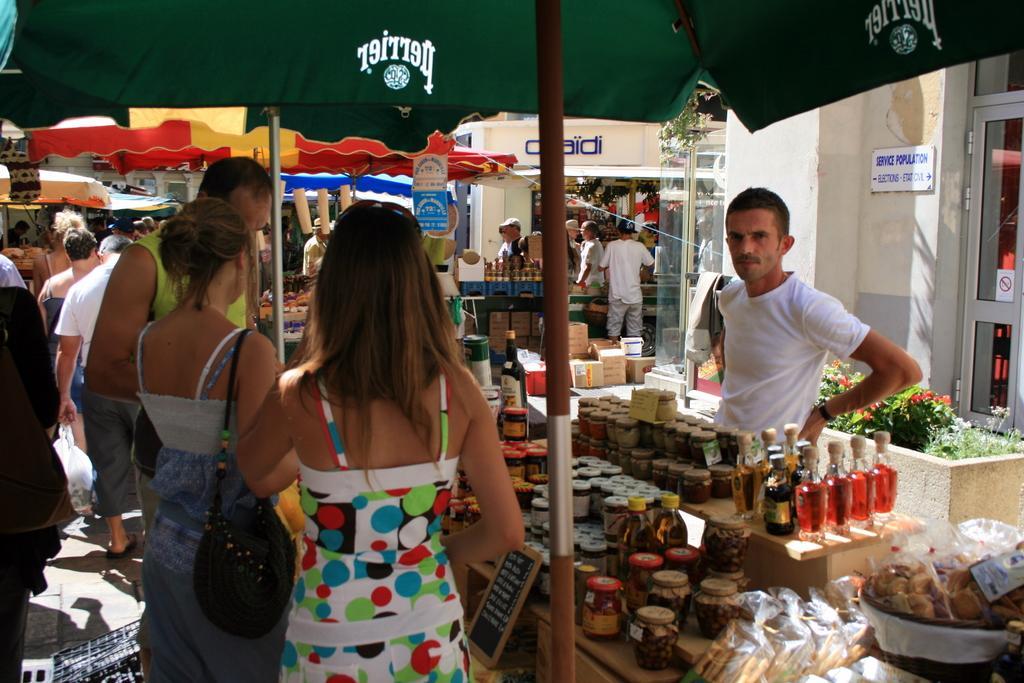Can you describe this image briefly? This image consists of many people. In the front, the man is wearing white T-shirt. At the top, there is a tent. In the background, there are shops. To the right, there is a door along with a wall. 